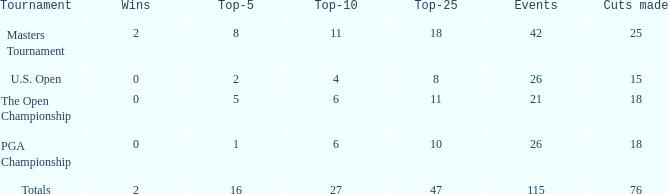How many average cuts made when 11 is the Top-10? 25.0. 